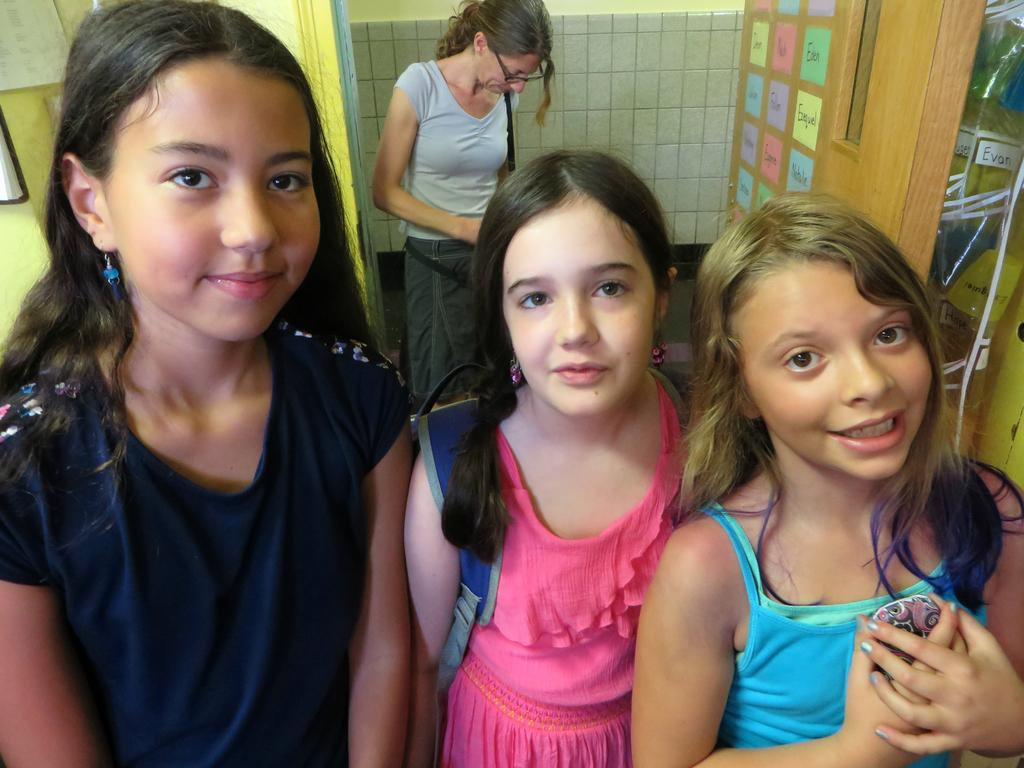How many people are present in the image? There are four people standing in the image. What can be observed about the clothing of the people in the image? The people are wearing different color dresses. What is the color of the wall in the background of the image? There is a white wall in the background of the image. What is attached to the wooden wall in the background? Colorful papers are attached to a wooden wall in the background. What type of lace can be seen on the jail bars in the image? There is no jail or lace present in the image. 